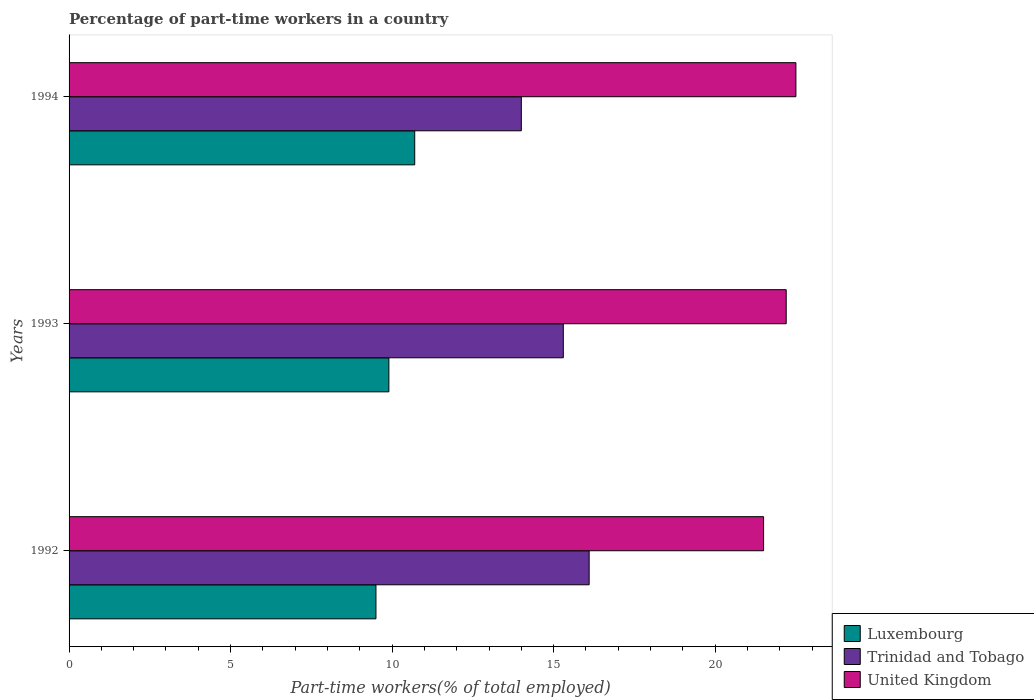How many groups of bars are there?
Ensure brevity in your answer.  3. Are the number of bars per tick equal to the number of legend labels?
Your response must be concise. Yes. Are the number of bars on each tick of the Y-axis equal?
Your answer should be compact. Yes. In how many cases, is the number of bars for a given year not equal to the number of legend labels?
Ensure brevity in your answer.  0. What is the percentage of part-time workers in United Kingdom in 1993?
Provide a short and direct response. 22.2. What is the total percentage of part-time workers in Trinidad and Tobago in the graph?
Your answer should be compact. 45.4. What is the difference between the percentage of part-time workers in Trinidad and Tobago in 1993 and that in 1994?
Offer a very short reply. 1.3. What is the difference between the percentage of part-time workers in Luxembourg in 1993 and the percentage of part-time workers in United Kingdom in 1992?
Provide a short and direct response. -11.6. What is the average percentage of part-time workers in Trinidad and Tobago per year?
Provide a succinct answer. 15.13. In the year 1993, what is the difference between the percentage of part-time workers in United Kingdom and percentage of part-time workers in Luxembourg?
Provide a short and direct response. 12.3. What is the ratio of the percentage of part-time workers in Trinidad and Tobago in 1992 to that in 1994?
Provide a succinct answer. 1.15. Is the difference between the percentage of part-time workers in United Kingdom in 1993 and 1994 greater than the difference between the percentage of part-time workers in Luxembourg in 1993 and 1994?
Your answer should be very brief. Yes. What is the difference between the highest and the second highest percentage of part-time workers in Luxembourg?
Offer a terse response. 0.8. What is the difference between the highest and the lowest percentage of part-time workers in Luxembourg?
Ensure brevity in your answer.  1.2. In how many years, is the percentage of part-time workers in Luxembourg greater than the average percentage of part-time workers in Luxembourg taken over all years?
Give a very brief answer. 1. What does the 3rd bar from the top in 1993 represents?
Ensure brevity in your answer.  Luxembourg. What does the 2nd bar from the bottom in 1993 represents?
Provide a succinct answer. Trinidad and Tobago. Are all the bars in the graph horizontal?
Your answer should be very brief. Yes. How many years are there in the graph?
Offer a terse response. 3. What is the difference between two consecutive major ticks on the X-axis?
Ensure brevity in your answer.  5. How are the legend labels stacked?
Your answer should be compact. Vertical. What is the title of the graph?
Give a very brief answer. Percentage of part-time workers in a country. What is the label or title of the X-axis?
Provide a short and direct response. Part-time workers(% of total employed). What is the Part-time workers(% of total employed) of Luxembourg in 1992?
Provide a short and direct response. 9.5. What is the Part-time workers(% of total employed) in Trinidad and Tobago in 1992?
Offer a very short reply. 16.1. What is the Part-time workers(% of total employed) of United Kingdom in 1992?
Your answer should be very brief. 21.5. What is the Part-time workers(% of total employed) in Luxembourg in 1993?
Provide a short and direct response. 9.9. What is the Part-time workers(% of total employed) of Trinidad and Tobago in 1993?
Give a very brief answer. 15.3. What is the Part-time workers(% of total employed) in United Kingdom in 1993?
Ensure brevity in your answer.  22.2. What is the Part-time workers(% of total employed) in Luxembourg in 1994?
Provide a short and direct response. 10.7. What is the Part-time workers(% of total employed) of Trinidad and Tobago in 1994?
Your answer should be compact. 14. What is the Part-time workers(% of total employed) of United Kingdom in 1994?
Keep it short and to the point. 22.5. Across all years, what is the maximum Part-time workers(% of total employed) of Luxembourg?
Offer a terse response. 10.7. Across all years, what is the maximum Part-time workers(% of total employed) in Trinidad and Tobago?
Give a very brief answer. 16.1. Across all years, what is the maximum Part-time workers(% of total employed) in United Kingdom?
Make the answer very short. 22.5. Across all years, what is the minimum Part-time workers(% of total employed) of United Kingdom?
Offer a terse response. 21.5. What is the total Part-time workers(% of total employed) in Luxembourg in the graph?
Your answer should be compact. 30.1. What is the total Part-time workers(% of total employed) of Trinidad and Tobago in the graph?
Your response must be concise. 45.4. What is the total Part-time workers(% of total employed) of United Kingdom in the graph?
Provide a succinct answer. 66.2. What is the difference between the Part-time workers(% of total employed) of Trinidad and Tobago in 1992 and that in 1994?
Provide a succinct answer. 2.1. What is the difference between the Part-time workers(% of total employed) in United Kingdom in 1993 and that in 1994?
Provide a short and direct response. -0.3. What is the difference between the Part-time workers(% of total employed) of Luxembourg in 1993 and the Part-time workers(% of total employed) of Trinidad and Tobago in 1994?
Provide a short and direct response. -4.1. What is the difference between the Part-time workers(% of total employed) of Trinidad and Tobago in 1993 and the Part-time workers(% of total employed) of United Kingdom in 1994?
Offer a very short reply. -7.2. What is the average Part-time workers(% of total employed) in Luxembourg per year?
Offer a very short reply. 10.03. What is the average Part-time workers(% of total employed) of Trinidad and Tobago per year?
Provide a succinct answer. 15.13. What is the average Part-time workers(% of total employed) in United Kingdom per year?
Provide a short and direct response. 22.07. In the year 1992, what is the difference between the Part-time workers(% of total employed) of Luxembourg and Part-time workers(% of total employed) of Trinidad and Tobago?
Provide a succinct answer. -6.6. In the year 1992, what is the difference between the Part-time workers(% of total employed) of Trinidad and Tobago and Part-time workers(% of total employed) of United Kingdom?
Make the answer very short. -5.4. In the year 1993, what is the difference between the Part-time workers(% of total employed) of Luxembourg and Part-time workers(% of total employed) of United Kingdom?
Provide a short and direct response. -12.3. In the year 1993, what is the difference between the Part-time workers(% of total employed) of Trinidad and Tobago and Part-time workers(% of total employed) of United Kingdom?
Give a very brief answer. -6.9. In the year 1994, what is the difference between the Part-time workers(% of total employed) in Luxembourg and Part-time workers(% of total employed) in Trinidad and Tobago?
Make the answer very short. -3.3. What is the ratio of the Part-time workers(% of total employed) in Luxembourg in 1992 to that in 1993?
Offer a very short reply. 0.96. What is the ratio of the Part-time workers(% of total employed) of Trinidad and Tobago in 1992 to that in 1993?
Keep it short and to the point. 1.05. What is the ratio of the Part-time workers(% of total employed) of United Kingdom in 1992 to that in 1993?
Make the answer very short. 0.97. What is the ratio of the Part-time workers(% of total employed) in Luxembourg in 1992 to that in 1994?
Provide a short and direct response. 0.89. What is the ratio of the Part-time workers(% of total employed) in Trinidad and Tobago in 1992 to that in 1994?
Your answer should be compact. 1.15. What is the ratio of the Part-time workers(% of total employed) of United Kingdom in 1992 to that in 1994?
Offer a very short reply. 0.96. What is the ratio of the Part-time workers(% of total employed) in Luxembourg in 1993 to that in 1994?
Keep it short and to the point. 0.93. What is the ratio of the Part-time workers(% of total employed) of Trinidad and Tobago in 1993 to that in 1994?
Provide a short and direct response. 1.09. What is the ratio of the Part-time workers(% of total employed) of United Kingdom in 1993 to that in 1994?
Your answer should be very brief. 0.99. What is the difference between the highest and the lowest Part-time workers(% of total employed) in Luxembourg?
Keep it short and to the point. 1.2. What is the difference between the highest and the lowest Part-time workers(% of total employed) in Trinidad and Tobago?
Ensure brevity in your answer.  2.1. What is the difference between the highest and the lowest Part-time workers(% of total employed) in United Kingdom?
Ensure brevity in your answer.  1. 